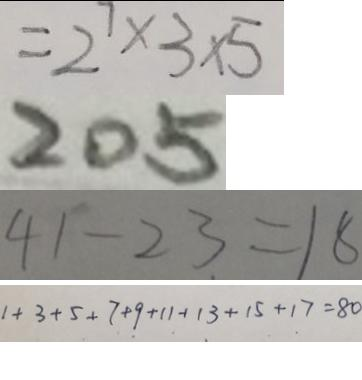Convert formula to latex. <formula><loc_0><loc_0><loc_500><loc_500>= 2 ^ { 7 } \times 3 \times 5 
 2 0 5 
 4 1 - 2 3 = 1 8 
 1 + 3 + 5 + 7 + 9 + 1 1 + 1 3 + 1 5 + 1 7 = 8 0</formula> 